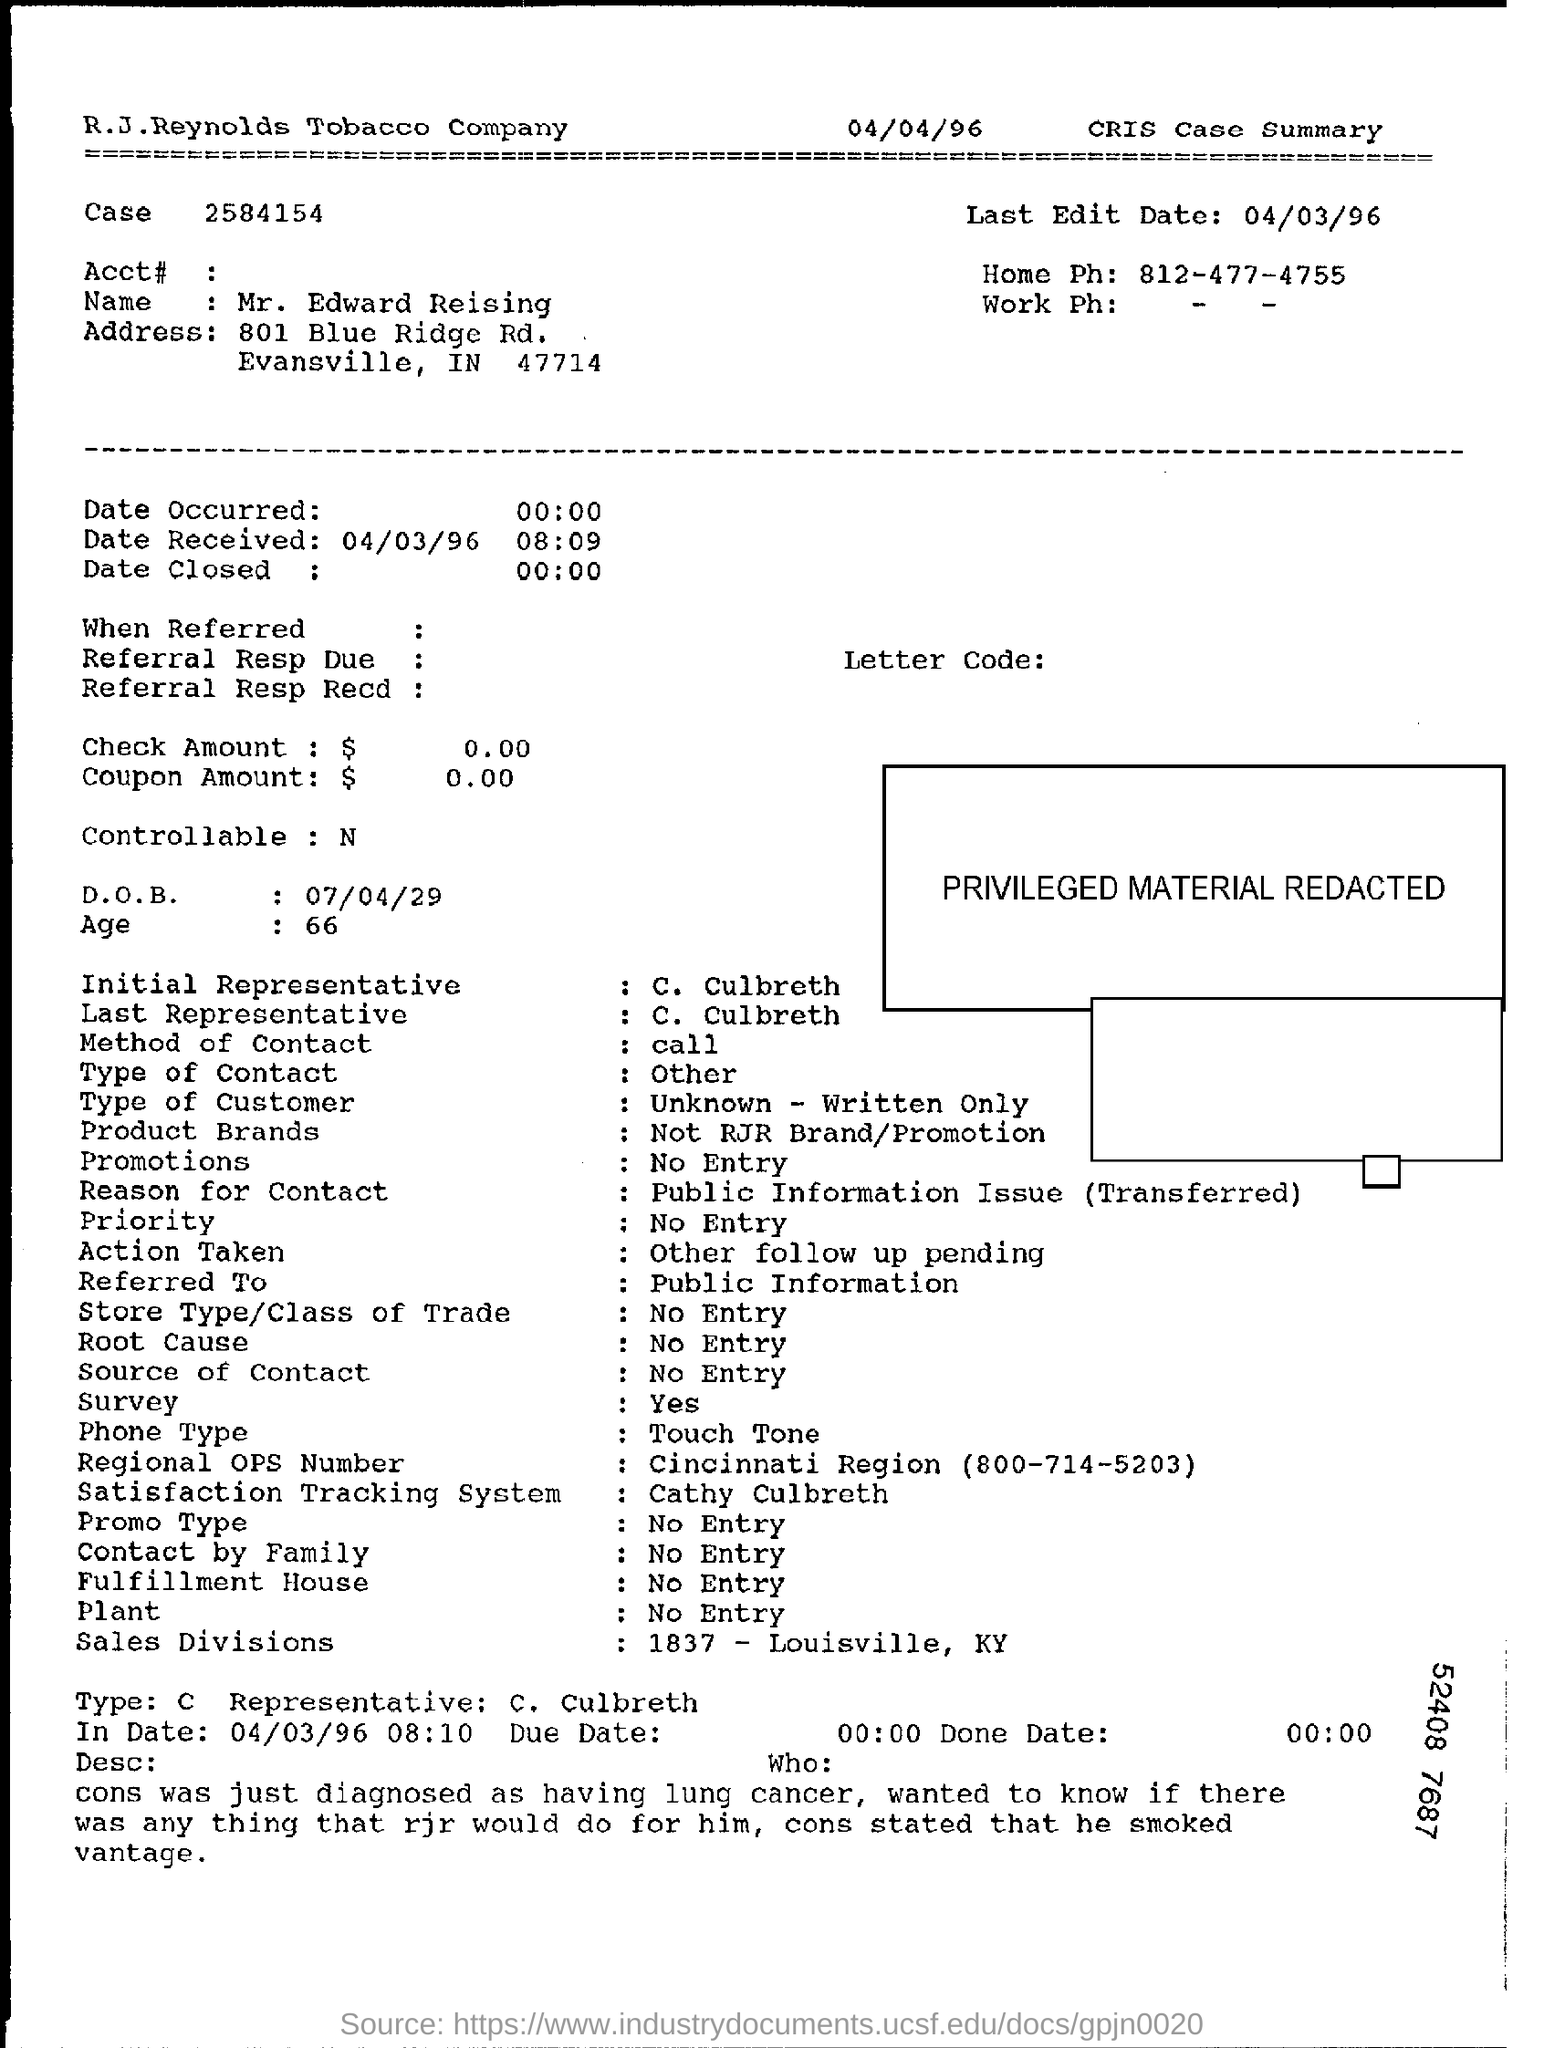Draw attention to some important aspects in this diagram. On what date was the received date? The initial representative is C. Culbreth. What is the name of the individual in question? Mr. Edward Reising. The age is 66. The home phone number is 812-477-4755. 